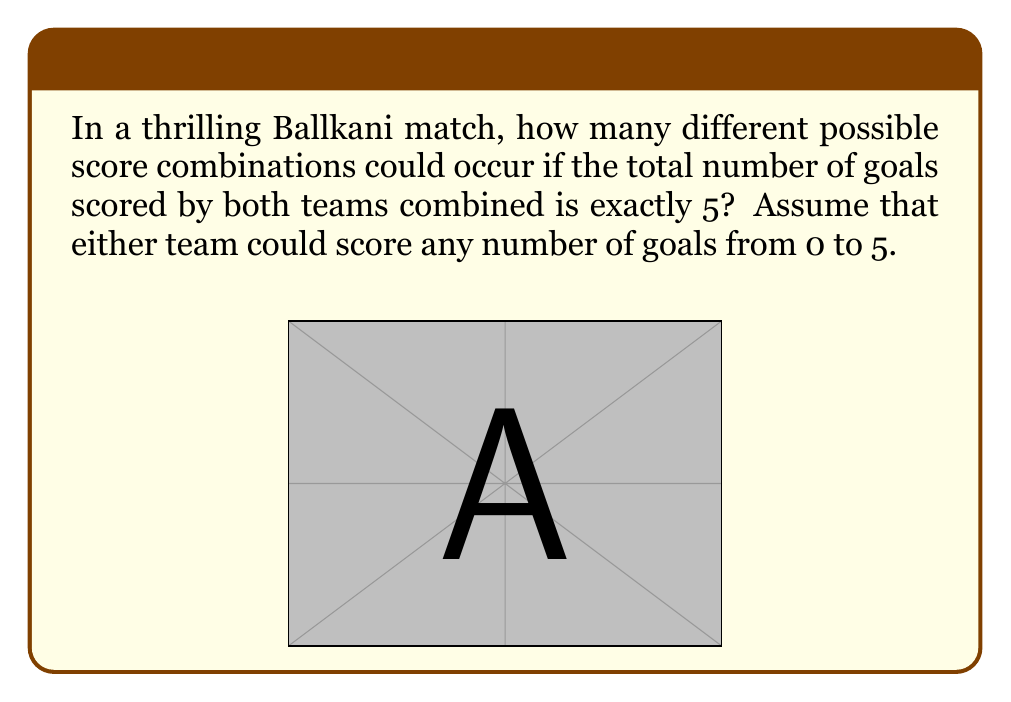Help me with this question. Let's approach this step-by-step:

1) First, we need to understand that the score combination is determined by how the 5 goals are distributed between the two teams.

2) We can represent this as an equation:
   $x + y = 5$, where $x$ is the number of goals scored by Ballkani and $y$ is the number of goals scored by the opponent.

3) Now, we need to find all the possible non-negative integer solutions for this equation. The possibilities are:

   $(5,0), (4,1), (3,2), (2,3), (1,4), (0,5)$

4) Each of these represents a unique score combination. For example, (5,0) means Ballkani won 5-0, while (2,3) means Ballkani lost 2-3.

5) To count the total number of combinations, we simply need to count these possibilities.

6) The number of possibilities is equal to $5 + 1 = 6$, because $x$ can take any value from 0 to 5 (6 possibilities), and $y$ is then determined.

7) Mathematically, this is equivalent to the number of ways to choose $x$ from $5+1$ items, which is denoted as $\binom{5+1}{1} = 6$.

Therefore, there are 6 different possible score combinations.
Answer: 6 